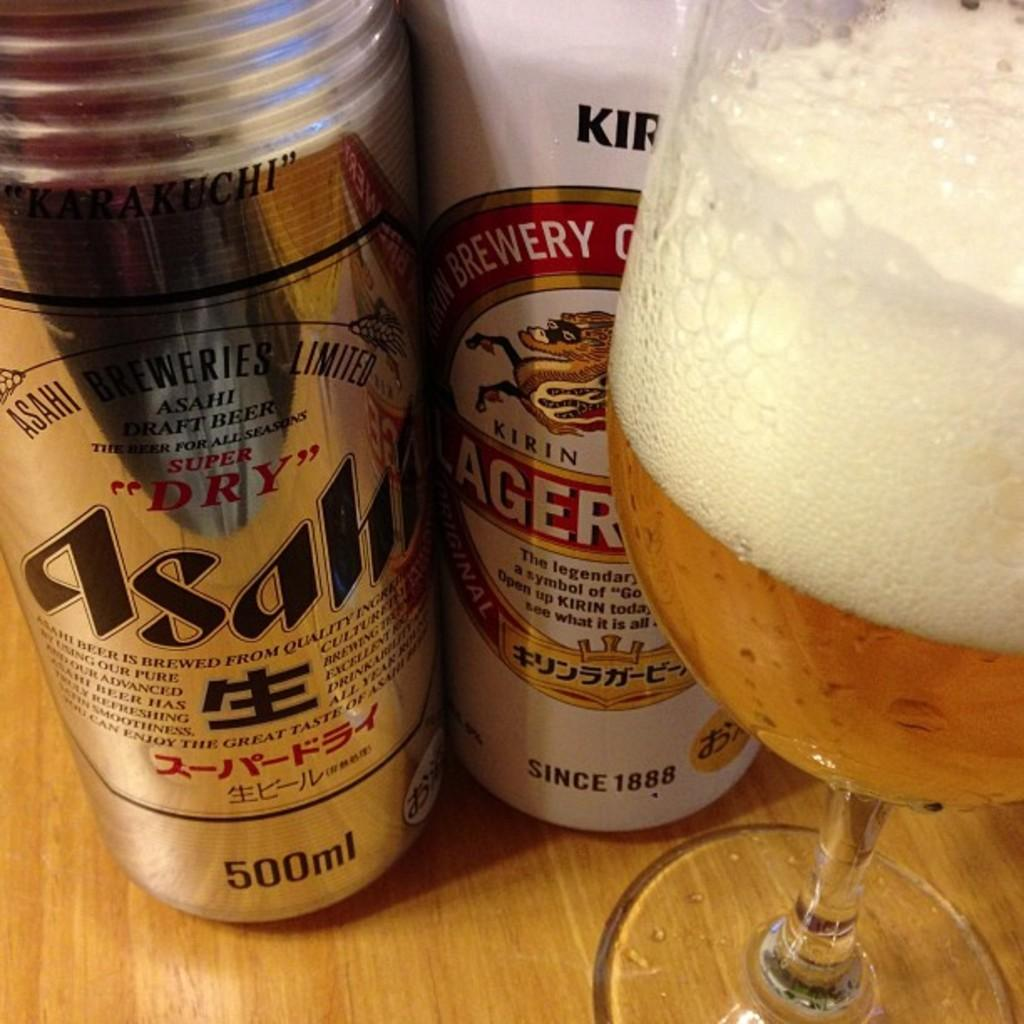Provide a one-sentence caption for the provided image. A can of Asahi beer, a can of Kirin Ichiban and a half full glass of beer. 